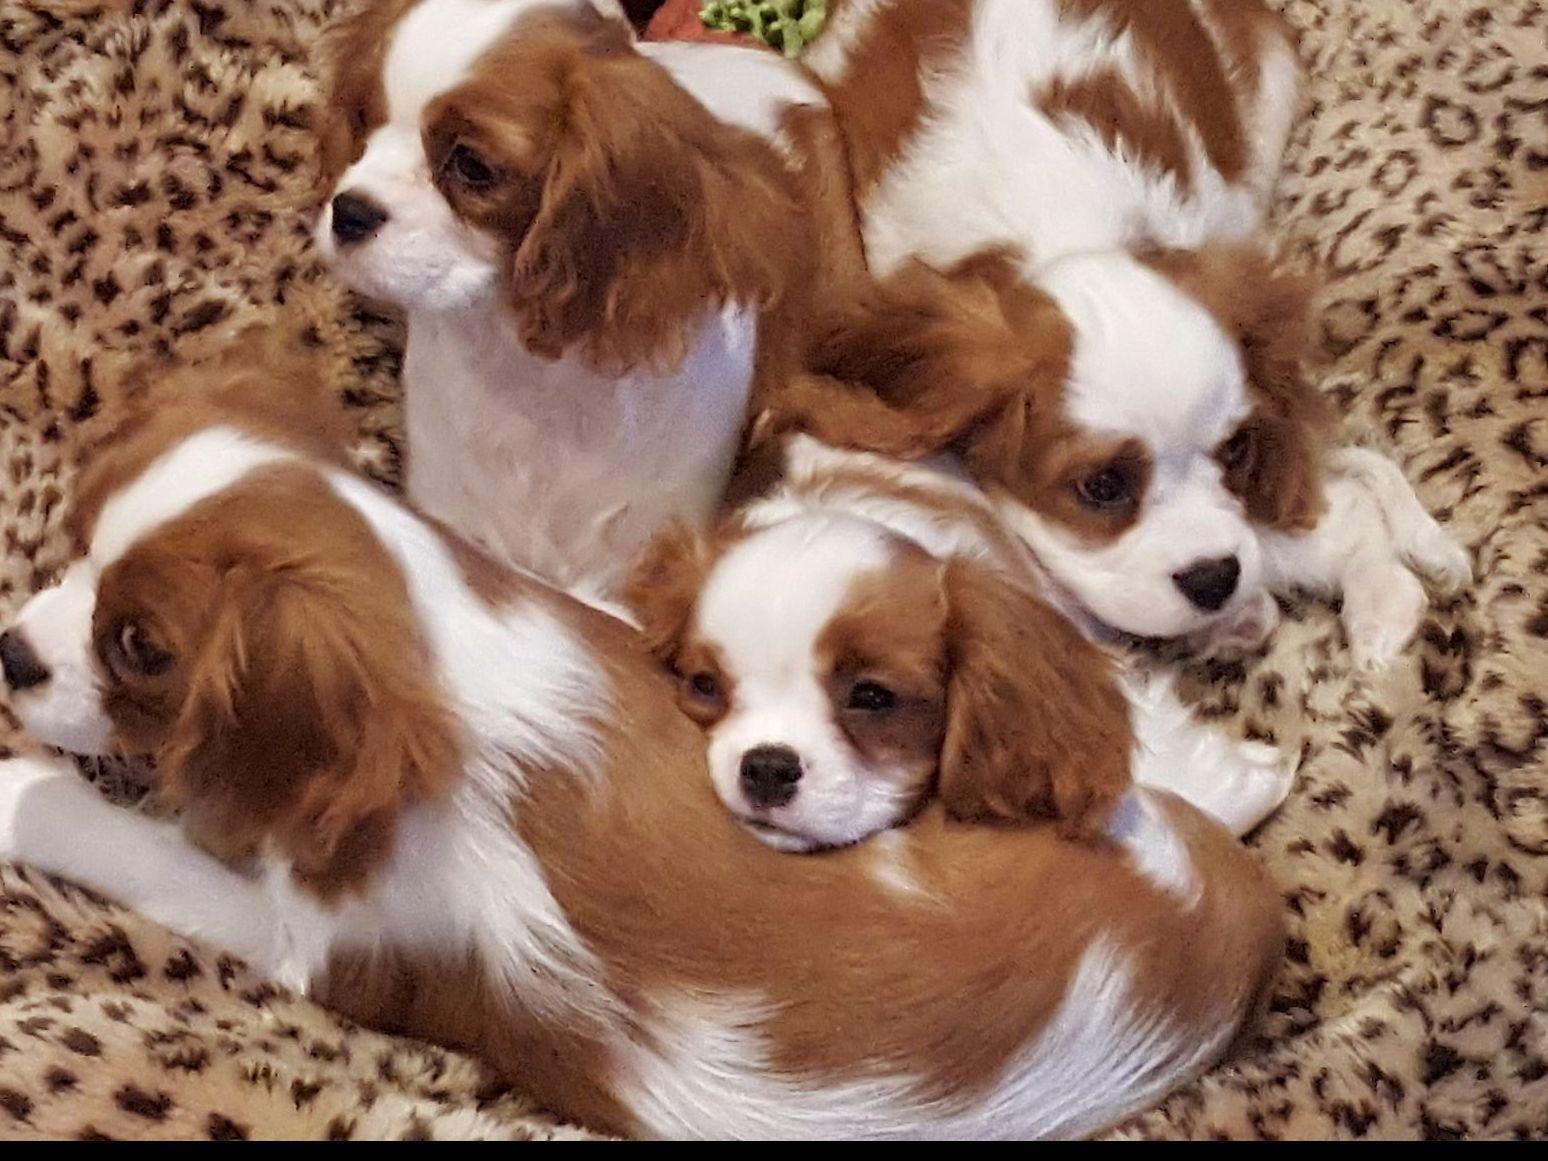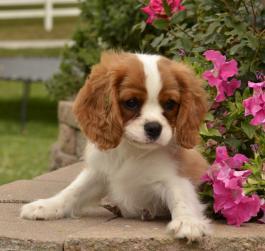The first image is the image on the left, the second image is the image on the right. Assess this claim about the two images: "An image features a cluster of only brown and white spaniel dogs.". Correct or not? Answer yes or no. Yes. The first image is the image on the left, the second image is the image on the right. Examine the images to the left and right. Is the description "One or more dogs are posed in front of pink flowers." accurate? Answer yes or no. Yes. 